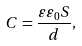Convert formula to latex. <formula><loc_0><loc_0><loc_500><loc_500>C = \frac { \varepsilon \varepsilon _ { 0 } S } { d } ,</formula> 